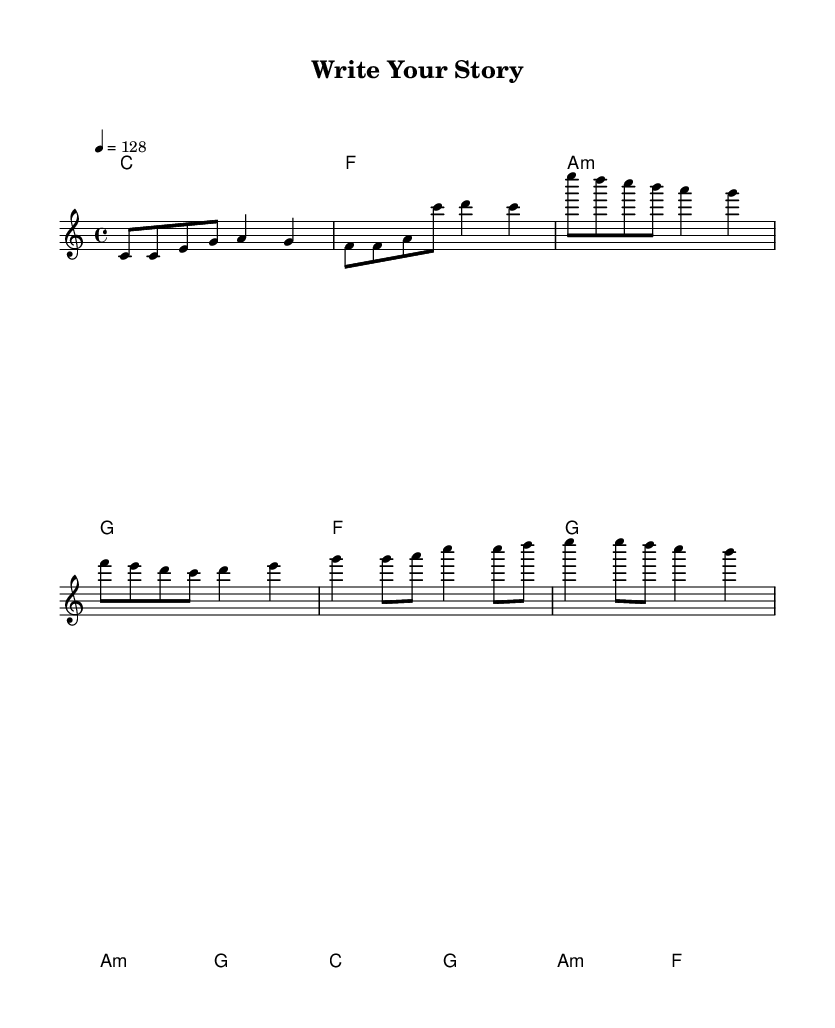What is the key signature of this music? The key signature is C major, which has no sharps or flats indicated in the staff at the beginning of the score.
Answer: C major What is the time signature? The time signature is 4/4, which shows that each measure contains four beats, and the quarter note gets one beat. This is indicated at the beginning of the score.
Answer: 4/4 What is the tempo marking? The tempo marking is 128 beats per minute, indicated in the score as "4 = 128". This means the quarter note is set to a pace of 128 beats per minute.
Answer: 128 How many measures are in the chorus section? The chorus section consists of four measures, as outlined in the score with specific melody and harmony notes for that part.
Answer: 4 What chord follows the A minor chord in the verse? The chord following the A minor chord in the verse is G, as indicated in the chord progression below the melody.
Answer: G What is the main theme of the lyrics? The main theme of the lyrics focuses on writing and inspiration, emphasizing the importance of creating one's own story. This can be inferred from the lines that encourage taking risks and making writing shine.
Answer: Writing and inspiration What type of electronic music does this song reflect? This song reflects an upbeat electronic pop style, characterized by a lively tempo, catchy melodies, and motivational lyrics that encourage creativity.
Answer: Upbeat electronic pop 